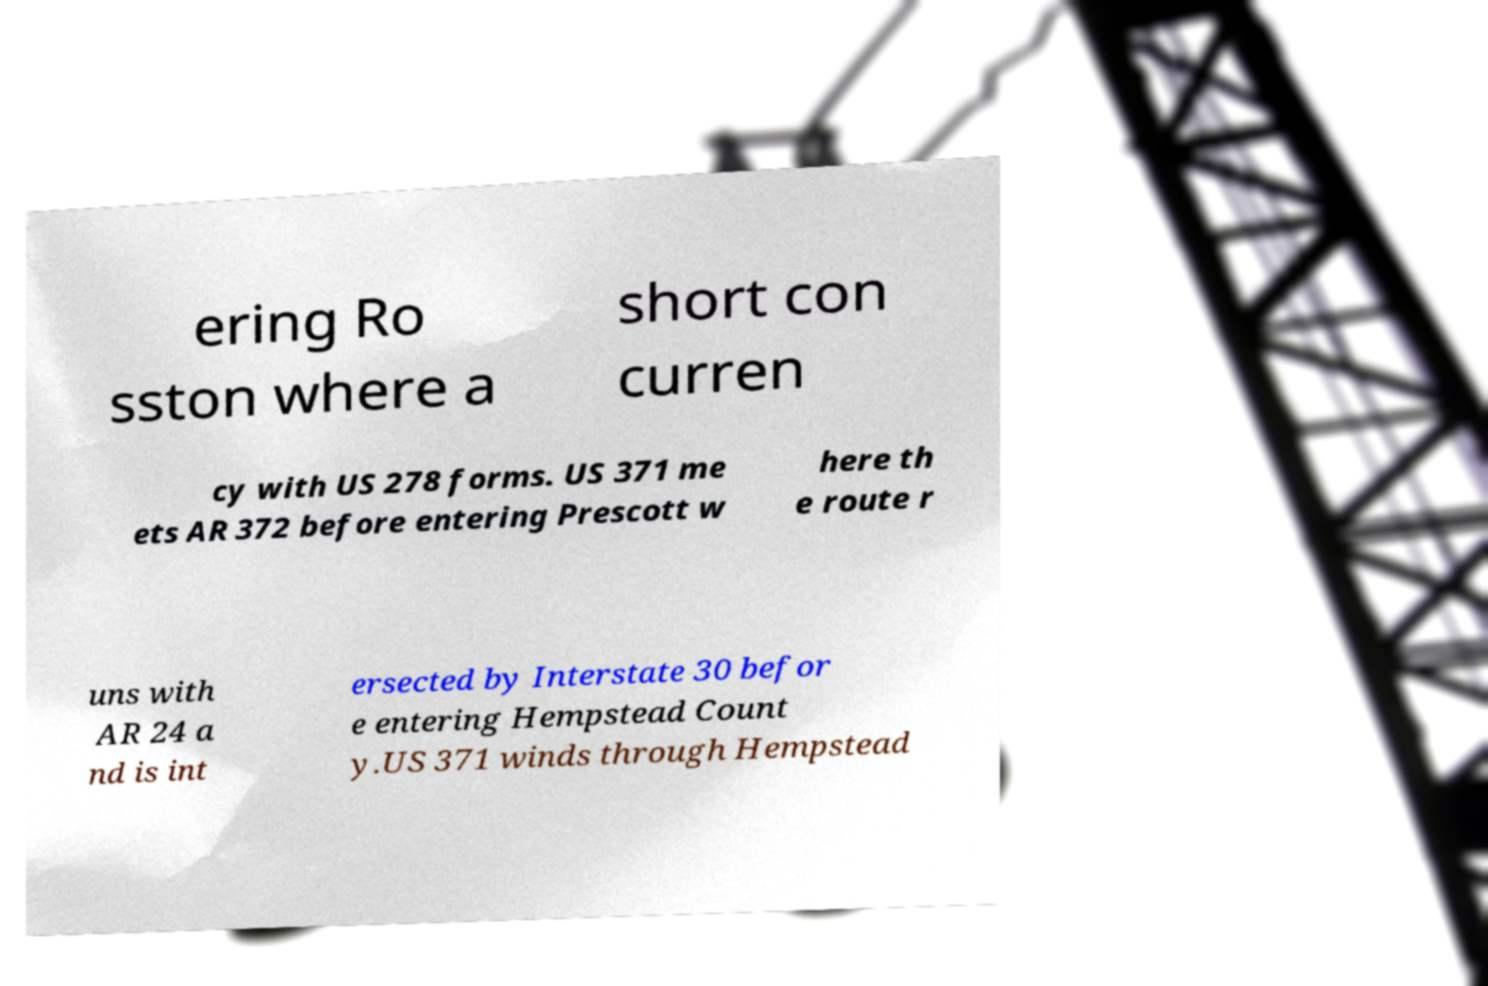What messages or text are displayed in this image? I need them in a readable, typed format. ering Ro sston where a short con curren cy with US 278 forms. US 371 me ets AR 372 before entering Prescott w here th e route r uns with AR 24 a nd is int ersected by Interstate 30 befor e entering Hempstead Count y.US 371 winds through Hempstead 